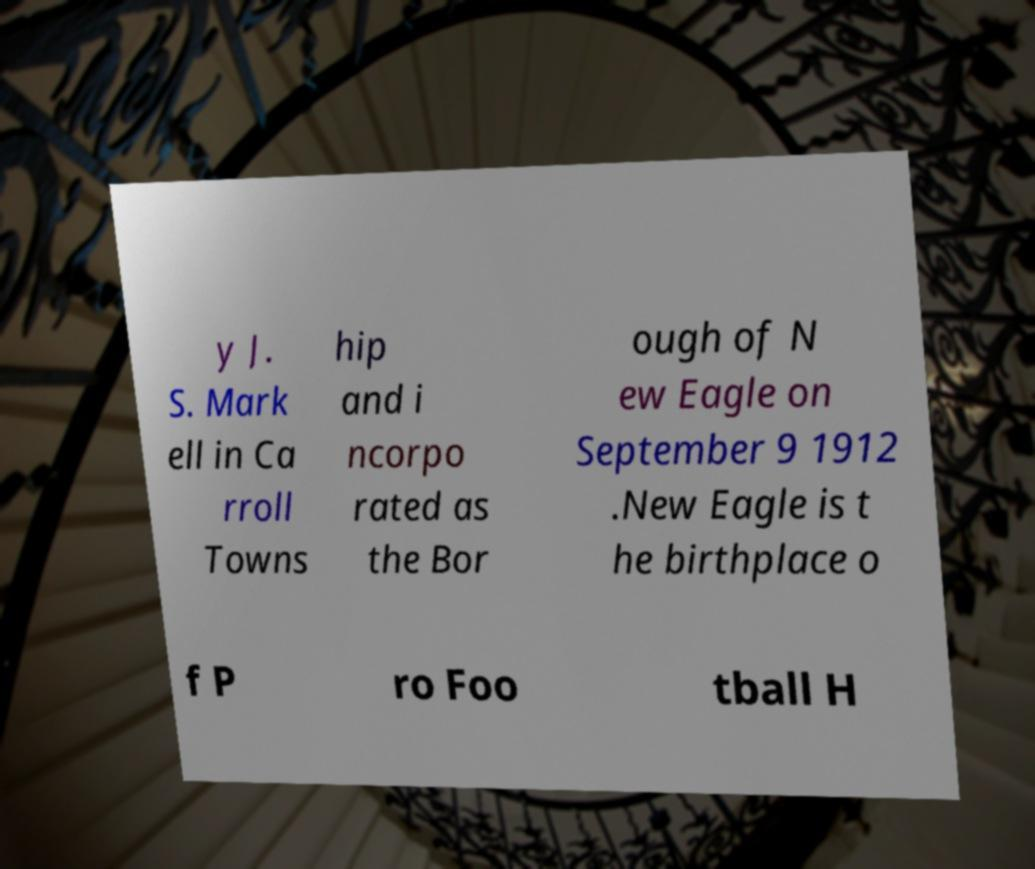For documentation purposes, I need the text within this image transcribed. Could you provide that? y J. S. Mark ell in Ca rroll Towns hip and i ncorpo rated as the Bor ough of N ew Eagle on September 9 1912 .New Eagle is t he birthplace o f P ro Foo tball H 